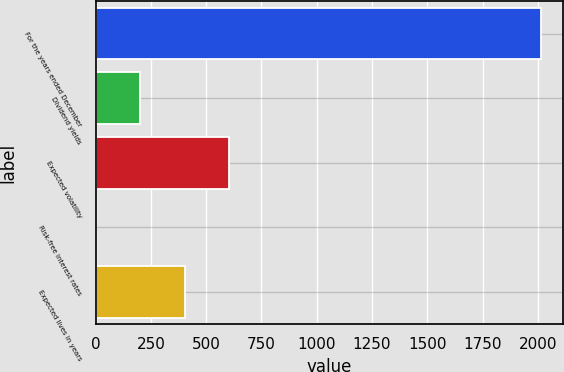Convert chart to OTSL. <chart><loc_0><loc_0><loc_500><loc_500><bar_chart><fcel>For the years ended December<fcel>Dividend yields<fcel>Expected volatility<fcel>Risk-free interest rates<fcel>Expected lives in years<nl><fcel>2012<fcel>202.55<fcel>604.65<fcel>1.5<fcel>403.6<nl></chart> 